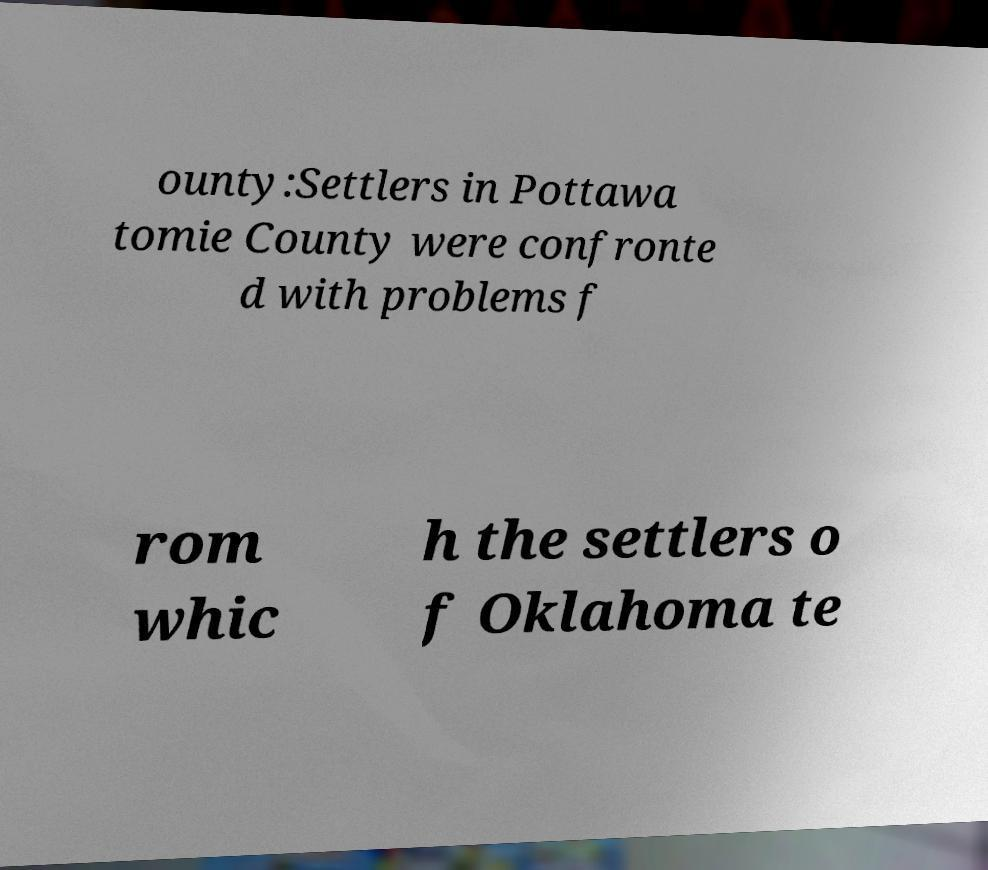Could you assist in decoding the text presented in this image and type it out clearly? ounty:Settlers in Pottawa tomie County were confronte d with problems f rom whic h the settlers o f Oklahoma te 